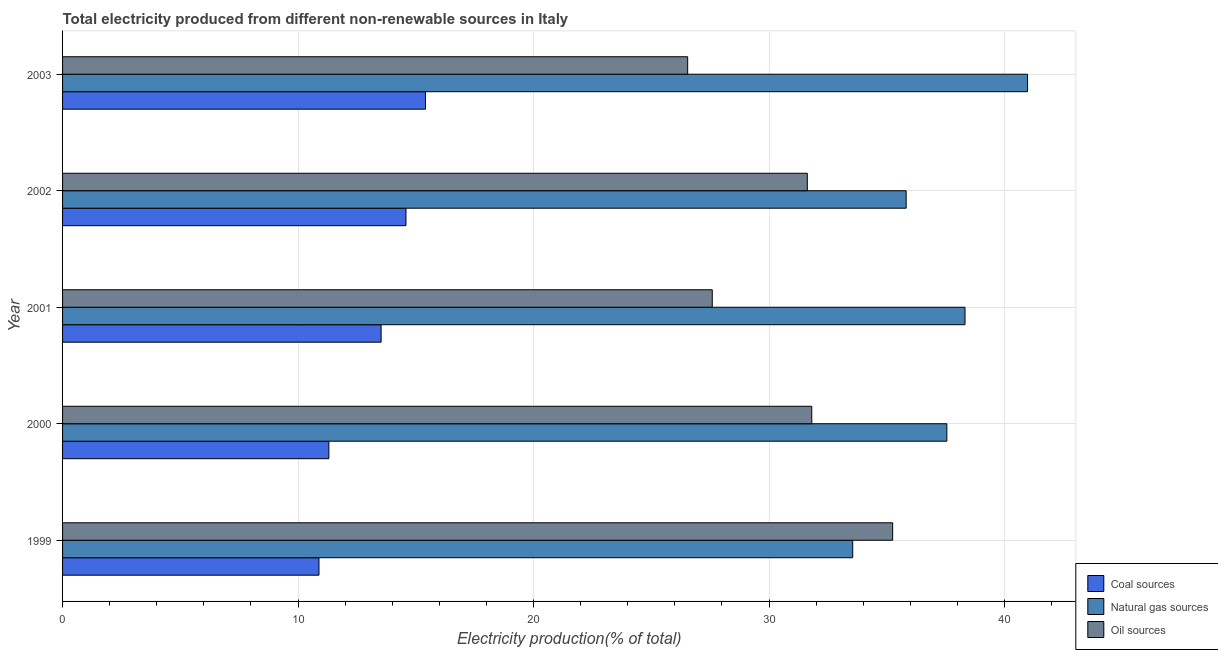How many different coloured bars are there?
Keep it short and to the point. 3. Are the number of bars per tick equal to the number of legend labels?
Ensure brevity in your answer.  Yes. Are the number of bars on each tick of the Y-axis equal?
Your answer should be very brief. Yes. How many bars are there on the 4th tick from the bottom?
Keep it short and to the point. 3. What is the label of the 2nd group of bars from the top?
Give a very brief answer. 2002. In how many cases, is the number of bars for a given year not equal to the number of legend labels?
Ensure brevity in your answer.  0. What is the percentage of electricity produced by oil sources in 1999?
Your response must be concise. 35.25. Across all years, what is the maximum percentage of electricity produced by coal?
Your answer should be compact. 15.41. Across all years, what is the minimum percentage of electricity produced by natural gas?
Your answer should be very brief. 33.55. In which year was the percentage of electricity produced by oil sources maximum?
Your response must be concise. 1999. What is the total percentage of electricity produced by natural gas in the graph?
Your response must be concise. 186.21. What is the difference between the percentage of electricity produced by natural gas in 2002 and that in 2003?
Keep it short and to the point. -5.15. What is the difference between the percentage of electricity produced by natural gas in 2001 and the percentage of electricity produced by coal in 1999?
Provide a succinct answer. 27.43. What is the average percentage of electricity produced by oil sources per year?
Ensure brevity in your answer.  30.56. In the year 2002, what is the difference between the percentage of electricity produced by coal and percentage of electricity produced by natural gas?
Provide a succinct answer. -21.24. In how many years, is the percentage of electricity produced by natural gas greater than 18 %?
Your answer should be compact. 5. What is the ratio of the percentage of electricity produced by oil sources in 1999 to that in 2001?
Ensure brevity in your answer.  1.28. Is the percentage of electricity produced by coal in 2000 less than that in 2002?
Offer a very short reply. Yes. Is the difference between the percentage of electricity produced by natural gas in 2000 and 2001 greater than the difference between the percentage of electricity produced by coal in 2000 and 2001?
Ensure brevity in your answer.  Yes. What is the difference between the highest and the second highest percentage of electricity produced by natural gas?
Offer a terse response. 2.65. What is the difference between the highest and the lowest percentage of electricity produced by coal?
Provide a succinct answer. 4.52. In how many years, is the percentage of electricity produced by oil sources greater than the average percentage of electricity produced by oil sources taken over all years?
Provide a short and direct response. 3. Is the sum of the percentage of electricity produced by coal in 2000 and 2001 greater than the maximum percentage of electricity produced by oil sources across all years?
Your response must be concise. No. What does the 1st bar from the top in 2000 represents?
Offer a terse response. Oil sources. What does the 1st bar from the bottom in 2000 represents?
Keep it short and to the point. Coal sources. Are all the bars in the graph horizontal?
Offer a terse response. Yes. What is the difference between two consecutive major ticks on the X-axis?
Provide a succinct answer. 10. Are the values on the major ticks of X-axis written in scientific E-notation?
Provide a short and direct response. No. Does the graph contain any zero values?
Provide a succinct answer. No. Where does the legend appear in the graph?
Make the answer very short. Bottom right. How many legend labels are there?
Offer a terse response. 3. What is the title of the graph?
Offer a terse response. Total electricity produced from different non-renewable sources in Italy. What is the label or title of the Y-axis?
Offer a terse response. Year. What is the Electricity production(% of total) in Coal sources in 1999?
Offer a very short reply. 10.89. What is the Electricity production(% of total) in Natural gas sources in 1999?
Ensure brevity in your answer.  33.55. What is the Electricity production(% of total) in Oil sources in 1999?
Provide a short and direct response. 35.25. What is the Electricity production(% of total) of Coal sources in 2000?
Your answer should be compact. 11.31. What is the Electricity production(% of total) of Natural gas sources in 2000?
Offer a terse response. 37.55. What is the Electricity production(% of total) in Oil sources in 2000?
Make the answer very short. 31.81. What is the Electricity production(% of total) in Coal sources in 2001?
Provide a short and direct response. 13.53. What is the Electricity production(% of total) in Natural gas sources in 2001?
Give a very brief answer. 38.32. What is the Electricity production(% of total) in Oil sources in 2001?
Ensure brevity in your answer.  27.59. What is the Electricity production(% of total) in Coal sources in 2002?
Make the answer very short. 14.58. What is the Electricity production(% of total) in Natural gas sources in 2002?
Make the answer very short. 35.82. What is the Electricity production(% of total) in Oil sources in 2002?
Your response must be concise. 31.62. What is the Electricity production(% of total) in Coal sources in 2003?
Provide a succinct answer. 15.41. What is the Electricity production(% of total) of Natural gas sources in 2003?
Ensure brevity in your answer.  40.97. What is the Electricity production(% of total) in Oil sources in 2003?
Provide a succinct answer. 26.54. Across all years, what is the maximum Electricity production(% of total) of Coal sources?
Make the answer very short. 15.41. Across all years, what is the maximum Electricity production(% of total) of Natural gas sources?
Keep it short and to the point. 40.97. Across all years, what is the maximum Electricity production(% of total) of Oil sources?
Your answer should be compact. 35.25. Across all years, what is the minimum Electricity production(% of total) of Coal sources?
Make the answer very short. 10.89. Across all years, what is the minimum Electricity production(% of total) in Natural gas sources?
Offer a very short reply. 33.55. Across all years, what is the minimum Electricity production(% of total) of Oil sources?
Give a very brief answer. 26.54. What is the total Electricity production(% of total) of Coal sources in the graph?
Your answer should be compact. 65.71. What is the total Electricity production(% of total) in Natural gas sources in the graph?
Your answer should be compact. 186.21. What is the total Electricity production(% of total) in Oil sources in the graph?
Provide a succinct answer. 152.81. What is the difference between the Electricity production(% of total) of Coal sources in 1999 and that in 2000?
Ensure brevity in your answer.  -0.42. What is the difference between the Electricity production(% of total) in Natural gas sources in 1999 and that in 2000?
Provide a succinct answer. -4. What is the difference between the Electricity production(% of total) in Oil sources in 1999 and that in 2000?
Ensure brevity in your answer.  3.43. What is the difference between the Electricity production(% of total) of Coal sources in 1999 and that in 2001?
Keep it short and to the point. -2.64. What is the difference between the Electricity production(% of total) in Natural gas sources in 1999 and that in 2001?
Make the answer very short. -4.77. What is the difference between the Electricity production(% of total) in Oil sources in 1999 and that in 2001?
Provide a succinct answer. 7.66. What is the difference between the Electricity production(% of total) of Coal sources in 1999 and that in 2002?
Offer a terse response. -3.69. What is the difference between the Electricity production(% of total) of Natural gas sources in 1999 and that in 2002?
Offer a very short reply. -2.27. What is the difference between the Electricity production(% of total) in Oil sources in 1999 and that in 2002?
Offer a terse response. 3.62. What is the difference between the Electricity production(% of total) in Coal sources in 1999 and that in 2003?
Your response must be concise. -4.52. What is the difference between the Electricity production(% of total) in Natural gas sources in 1999 and that in 2003?
Give a very brief answer. -7.42. What is the difference between the Electricity production(% of total) of Oil sources in 1999 and that in 2003?
Give a very brief answer. 8.7. What is the difference between the Electricity production(% of total) of Coal sources in 2000 and that in 2001?
Your response must be concise. -2.22. What is the difference between the Electricity production(% of total) in Natural gas sources in 2000 and that in 2001?
Offer a very short reply. -0.77. What is the difference between the Electricity production(% of total) in Oil sources in 2000 and that in 2001?
Ensure brevity in your answer.  4.23. What is the difference between the Electricity production(% of total) of Coal sources in 2000 and that in 2002?
Make the answer very short. -3.27. What is the difference between the Electricity production(% of total) in Natural gas sources in 2000 and that in 2002?
Keep it short and to the point. 1.73. What is the difference between the Electricity production(% of total) in Oil sources in 2000 and that in 2002?
Make the answer very short. 0.19. What is the difference between the Electricity production(% of total) of Coal sources in 2000 and that in 2003?
Offer a terse response. -4.1. What is the difference between the Electricity production(% of total) in Natural gas sources in 2000 and that in 2003?
Offer a terse response. -3.43. What is the difference between the Electricity production(% of total) in Oil sources in 2000 and that in 2003?
Provide a succinct answer. 5.27. What is the difference between the Electricity production(% of total) of Coal sources in 2001 and that in 2002?
Give a very brief answer. -1.06. What is the difference between the Electricity production(% of total) of Natural gas sources in 2001 and that in 2002?
Keep it short and to the point. 2.5. What is the difference between the Electricity production(% of total) of Oil sources in 2001 and that in 2002?
Offer a terse response. -4.04. What is the difference between the Electricity production(% of total) of Coal sources in 2001 and that in 2003?
Your answer should be compact. -1.89. What is the difference between the Electricity production(% of total) of Natural gas sources in 2001 and that in 2003?
Provide a short and direct response. -2.65. What is the difference between the Electricity production(% of total) of Oil sources in 2001 and that in 2003?
Give a very brief answer. 1.04. What is the difference between the Electricity production(% of total) of Coal sources in 2002 and that in 2003?
Provide a succinct answer. -0.83. What is the difference between the Electricity production(% of total) in Natural gas sources in 2002 and that in 2003?
Offer a terse response. -5.15. What is the difference between the Electricity production(% of total) in Oil sources in 2002 and that in 2003?
Your answer should be compact. 5.08. What is the difference between the Electricity production(% of total) of Coal sources in 1999 and the Electricity production(% of total) of Natural gas sources in 2000?
Make the answer very short. -26.66. What is the difference between the Electricity production(% of total) of Coal sources in 1999 and the Electricity production(% of total) of Oil sources in 2000?
Offer a terse response. -20.93. What is the difference between the Electricity production(% of total) of Natural gas sources in 1999 and the Electricity production(% of total) of Oil sources in 2000?
Your answer should be very brief. 1.74. What is the difference between the Electricity production(% of total) of Coal sources in 1999 and the Electricity production(% of total) of Natural gas sources in 2001?
Make the answer very short. -27.43. What is the difference between the Electricity production(% of total) of Coal sources in 1999 and the Electricity production(% of total) of Oil sources in 2001?
Your answer should be compact. -16.7. What is the difference between the Electricity production(% of total) of Natural gas sources in 1999 and the Electricity production(% of total) of Oil sources in 2001?
Provide a succinct answer. 5.96. What is the difference between the Electricity production(% of total) of Coal sources in 1999 and the Electricity production(% of total) of Natural gas sources in 2002?
Make the answer very short. -24.93. What is the difference between the Electricity production(% of total) of Coal sources in 1999 and the Electricity production(% of total) of Oil sources in 2002?
Give a very brief answer. -20.74. What is the difference between the Electricity production(% of total) of Natural gas sources in 1999 and the Electricity production(% of total) of Oil sources in 2002?
Your answer should be compact. 1.93. What is the difference between the Electricity production(% of total) of Coal sources in 1999 and the Electricity production(% of total) of Natural gas sources in 2003?
Your response must be concise. -30.09. What is the difference between the Electricity production(% of total) of Coal sources in 1999 and the Electricity production(% of total) of Oil sources in 2003?
Give a very brief answer. -15.66. What is the difference between the Electricity production(% of total) in Natural gas sources in 1999 and the Electricity production(% of total) in Oil sources in 2003?
Offer a terse response. 7.01. What is the difference between the Electricity production(% of total) in Coal sources in 2000 and the Electricity production(% of total) in Natural gas sources in 2001?
Keep it short and to the point. -27.01. What is the difference between the Electricity production(% of total) of Coal sources in 2000 and the Electricity production(% of total) of Oil sources in 2001?
Provide a succinct answer. -16.28. What is the difference between the Electricity production(% of total) in Natural gas sources in 2000 and the Electricity production(% of total) in Oil sources in 2001?
Your response must be concise. 9.96. What is the difference between the Electricity production(% of total) of Coal sources in 2000 and the Electricity production(% of total) of Natural gas sources in 2002?
Ensure brevity in your answer.  -24.51. What is the difference between the Electricity production(% of total) in Coal sources in 2000 and the Electricity production(% of total) in Oil sources in 2002?
Provide a short and direct response. -20.32. What is the difference between the Electricity production(% of total) in Natural gas sources in 2000 and the Electricity production(% of total) in Oil sources in 2002?
Your answer should be compact. 5.92. What is the difference between the Electricity production(% of total) in Coal sources in 2000 and the Electricity production(% of total) in Natural gas sources in 2003?
Provide a succinct answer. -29.67. What is the difference between the Electricity production(% of total) of Coal sources in 2000 and the Electricity production(% of total) of Oil sources in 2003?
Ensure brevity in your answer.  -15.24. What is the difference between the Electricity production(% of total) of Natural gas sources in 2000 and the Electricity production(% of total) of Oil sources in 2003?
Give a very brief answer. 11. What is the difference between the Electricity production(% of total) of Coal sources in 2001 and the Electricity production(% of total) of Natural gas sources in 2002?
Keep it short and to the point. -22.29. What is the difference between the Electricity production(% of total) in Coal sources in 2001 and the Electricity production(% of total) in Oil sources in 2002?
Provide a short and direct response. -18.1. What is the difference between the Electricity production(% of total) in Natural gas sources in 2001 and the Electricity production(% of total) in Oil sources in 2002?
Offer a very short reply. 6.7. What is the difference between the Electricity production(% of total) of Coal sources in 2001 and the Electricity production(% of total) of Natural gas sources in 2003?
Offer a very short reply. -27.45. What is the difference between the Electricity production(% of total) of Coal sources in 2001 and the Electricity production(% of total) of Oil sources in 2003?
Provide a succinct answer. -13.02. What is the difference between the Electricity production(% of total) in Natural gas sources in 2001 and the Electricity production(% of total) in Oil sources in 2003?
Provide a short and direct response. 11.78. What is the difference between the Electricity production(% of total) of Coal sources in 2002 and the Electricity production(% of total) of Natural gas sources in 2003?
Ensure brevity in your answer.  -26.39. What is the difference between the Electricity production(% of total) in Coal sources in 2002 and the Electricity production(% of total) in Oil sources in 2003?
Keep it short and to the point. -11.96. What is the difference between the Electricity production(% of total) in Natural gas sources in 2002 and the Electricity production(% of total) in Oil sources in 2003?
Provide a succinct answer. 9.28. What is the average Electricity production(% of total) in Coal sources per year?
Provide a succinct answer. 13.14. What is the average Electricity production(% of total) in Natural gas sources per year?
Provide a short and direct response. 37.24. What is the average Electricity production(% of total) of Oil sources per year?
Offer a very short reply. 30.56. In the year 1999, what is the difference between the Electricity production(% of total) in Coal sources and Electricity production(% of total) in Natural gas sources?
Provide a succinct answer. -22.66. In the year 1999, what is the difference between the Electricity production(% of total) in Coal sources and Electricity production(% of total) in Oil sources?
Provide a short and direct response. -24.36. In the year 1999, what is the difference between the Electricity production(% of total) in Natural gas sources and Electricity production(% of total) in Oil sources?
Provide a succinct answer. -1.7. In the year 2000, what is the difference between the Electricity production(% of total) in Coal sources and Electricity production(% of total) in Natural gas sources?
Provide a succinct answer. -26.24. In the year 2000, what is the difference between the Electricity production(% of total) of Coal sources and Electricity production(% of total) of Oil sources?
Ensure brevity in your answer.  -20.51. In the year 2000, what is the difference between the Electricity production(% of total) in Natural gas sources and Electricity production(% of total) in Oil sources?
Offer a very short reply. 5.74. In the year 2001, what is the difference between the Electricity production(% of total) of Coal sources and Electricity production(% of total) of Natural gas sources?
Offer a terse response. -24.79. In the year 2001, what is the difference between the Electricity production(% of total) of Coal sources and Electricity production(% of total) of Oil sources?
Your response must be concise. -14.06. In the year 2001, what is the difference between the Electricity production(% of total) in Natural gas sources and Electricity production(% of total) in Oil sources?
Give a very brief answer. 10.73. In the year 2002, what is the difference between the Electricity production(% of total) of Coal sources and Electricity production(% of total) of Natural gas sources?
Offer a very short reply. -21.24. In the year 2002, what is the difference between the Electricity production(% of total) in Coal sources and Electricity production(% of total) in Oil sources?
Make the answer very short. -17.04. In the year 2002, what is the difference between the Electricity production(% of total) in Natural gas sources and Electricity production(% of total) in Oil sources?
Ensure brevity in your answer.  4.2. In the year 2003, what is the difference between the Electricity production(% of total) of Coal sources and Electricity production(% of total) of Natural gas sources?
Your response must be concise. -25.56. In the year 2003, what is the difference between the Electricity production(% of total) of Coal sources and Electricity production(% of total) of Oil sources?
Give a very brief answer. -11.13. In the year 2003, what is the difference between the Electricity production(% of total) in Natural gas sources and Electricity production(% of total) in Oil sources?
Your answer should be compact. 14.43. What is the ratio of the Electricity production(% of total) of Coal sources in 1999 to that in 2000?
Make the answer very short. 0.96. What is the ratio of the Electricity production(% of total) in Natural gas sources in 1999 to that in 2000?
Provide a short and direct response. 0.89. What is the ratio of the Electricity production(% of total) of Oil sources in 1999 to that in 2000?
Provide a succinct answer. 1.11. What is the ratio of the Electricity production(% of total) of Coal sources in 1999 to that in 2001?
Ensure brevity in your answer.  0.8. What is the ratio of the Electricity production(% of total) in Natural gas sources in 1999 to that in 2001?
Ensure brevity in your answer.  0.88. What is the ratio of the Electricity production(% of total) in Oil sources in 1999 to that in 2001?
Provide a succinct answer. 1.28. What is the ratio of the Electricity production(% of total) in Coal sources in 1999 to that in 2002?
Your answer should be very brief. 0.75. What is the ratio of the Electricity production(% of total) in Natural gas sources in 1999 to that in 2002?
Provide a succinct answer. 0.94. What is the ratio of the Electricity production(% of total) of Oil sources in 1999 to that in 2002?
Your response must be concise. 1.11. What is the ratio of the Electricity production(% of total) of Coal sources in 1999 to that in 2003?
Your answer should be compact. 0.71. What is the ratio of the Electricity production(% of total) in Natural gas sources in 1999 to that in 2003?
Offer a terse response. 0.82. What is the ratio of the Electricity production(% of total) of Oil sources in 1999 to that in 2003?
Your response must be concise. 1.33. What is the ratio of the Electricity production(% of total) in Coal sources in 2000 to that in 2001?
Give a very brief answer. 0.84. What is the ratio of the Electricity production(% of total) in Natural gas sources in 2000 to that in 2001?
Offer a very short reply. 0.98. What is the ratio of the Electricity production(% of total) of Oil sources in 2000 to that in 2001?
Your response must be concise. 1.15. What is the ratio of the Electricity production(% of total) in Coal sources in 2000 to that in 2002?
Give a very brief answer. 0.78. What is the ratio of the Electricity production(% of total) in Natural gas sources in 2000 to that in 2002?
Your response must be concise. 1.05. What is the ratio of the Electricity production(% of total) in Oil sources in 2000 to that in 2002?
Offer a very short reply. 1.01. What is the ratio of the Electricity production(% of total) of Coal sources in 2000 to that in 2003?
Offer a very short reply. 0.73. What is the ratio of the Electricity production(% of total) in Natural gas sources in 2000 to that in 2003?
Ensure brevity in your answer.  0.92. What is the ratio of the Electricity production(% of total) in Oil sources in 2000 to that in 2003?
Keep it short and to the point. 1.2. What is the ratio of the Electricity production(% of total) in Coal sources in 2001 to that in 2002?
Offer a terse response. 0.93. What is the ratio of the Electricity production(% of total) of Natural gas sources in 2001 to that in 2002?
Offer a very short reply. 1.07. What is the ratio of the Electricity production(% of total) in Oil sources in 2001 to that in 2002?
Make the answer very short. 0.87. What is the ratio of the Electricity production(% of total) in Coal sources in 2001 to that in 2003?
Provide a succinct answer. 0.88. What is the ratio of the Electricity production(% of total) of Natural gas sources in 2001 to that in 2003?
Give a very brief answer. 0.94. What is the ratio of the Electricity production(% of total) of Oil sources in 2001 to that in 2003?
Make the answer very short. 1.04. What is the ratio of the Electricity production(% of total) in Coal sources in 2002 to that in 2003?
Ensure brevity in your answer.  0.95. What is the ratio of the Electricity production(% of total) in Natural gas sources in 2002 to that in 2003?
Provide a succinct answer. 0.87. What is the ratio of the Electricity production(% of total) of Oil sources in 2002 to that in 2003?
Your answer should be very brief. 1.19. What is the difference between the highest and the second highest Electricity production(% of total) in Coal sources?
Your response must be concise. 0.83. What is the difference between the highest and the second highest Electricity production(% of total) of Natural gas sources?
Keep it short and to the point. 2.65. What is the difference between the highest and the second highest Electricity production(% of total) of Oil sources?
Your answer should be very brief. 3.43. What is the difference between the highest and the lowest Electricity production(% of total) in Coal sources?
Give a very brief answer. 4.52. What is the difference between the highest and the lowest Electricity production(% of total) in Natural gas sources?
Ensure brevity in your answer.  7.42. What is the difference between the highest and the lowest Electricity production(% of total) of Oil sources?
Your response must be concise. 8.7. 